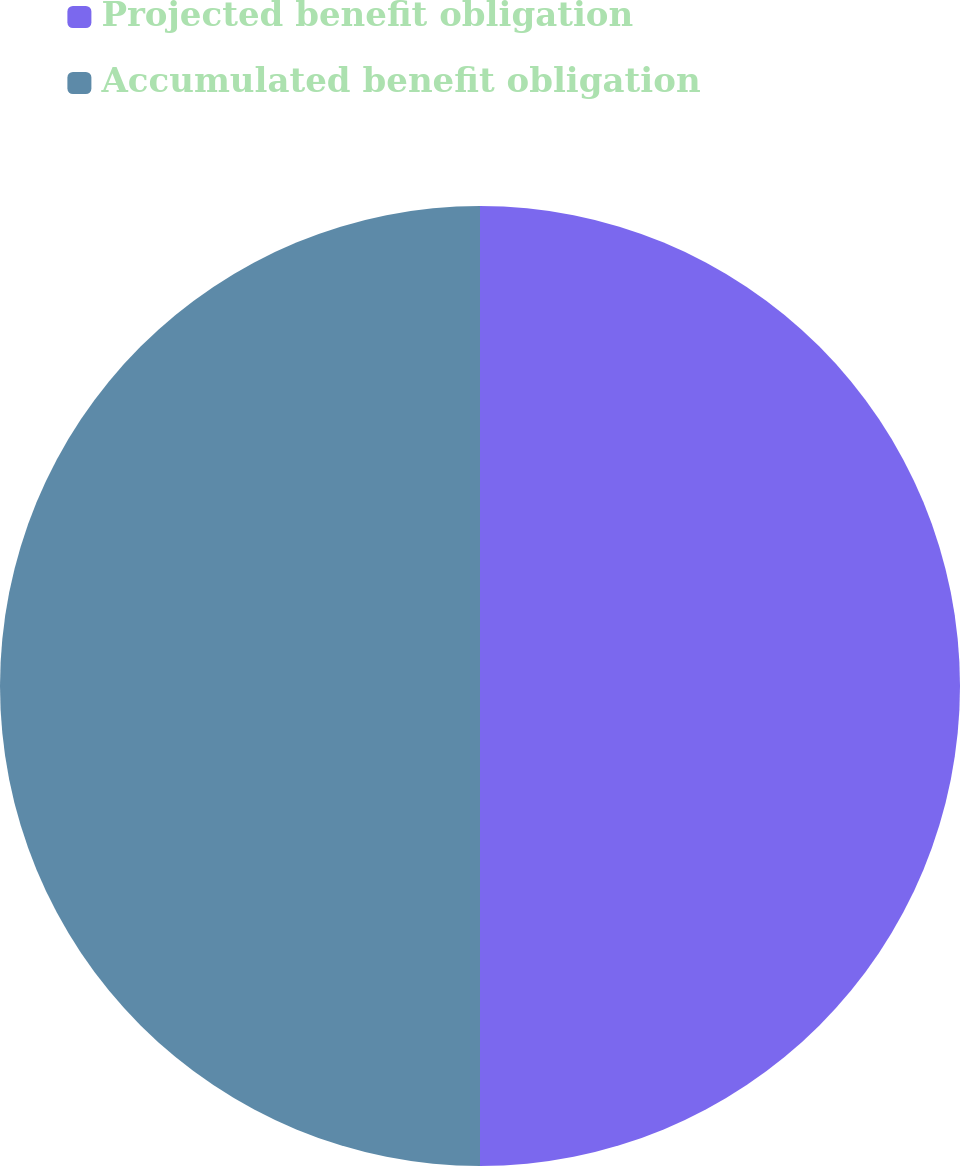<chart> <loc_0><loc_0><loc_500><loc_500><pie_chart><fcel>Projected benefit obligation<fcel>Accumulated benefit obligation<nl><fcel>50.0%<fcel>50.0%<nl></chart> 